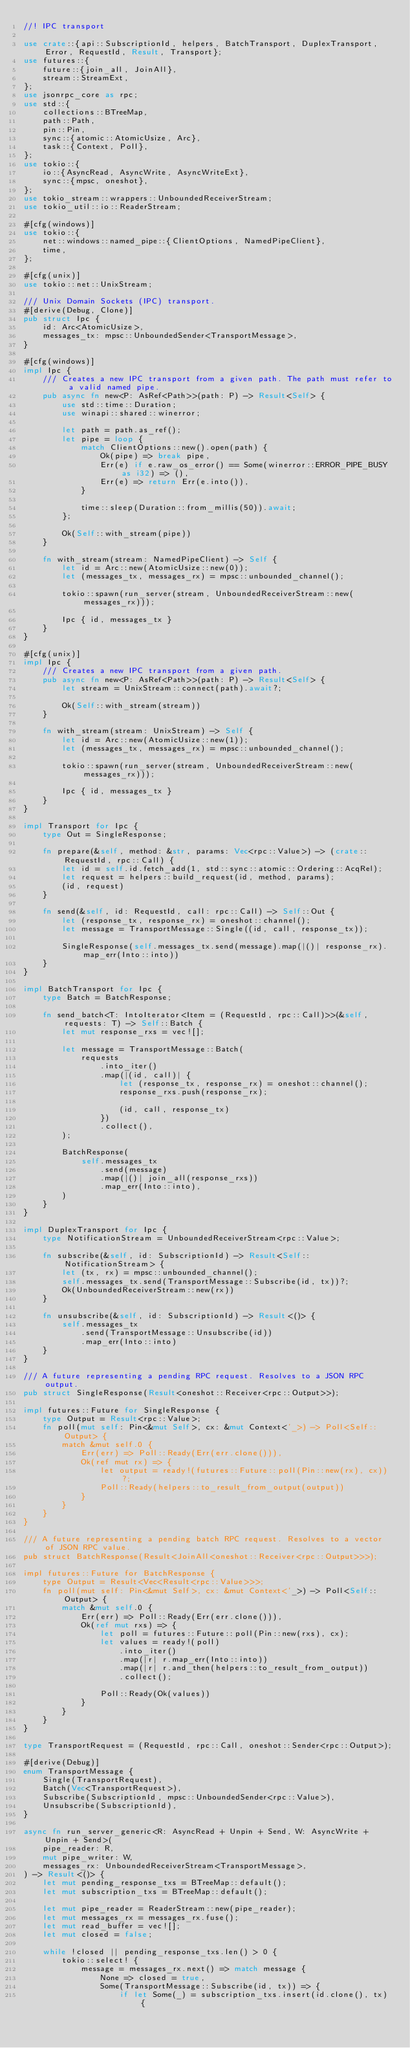<code> <loc_0><loc_0><loc_500><loc_500><_Rust_>//! IPC transport

use crate::{api::SubscriptionId, helpers, BatchTransport, DuplexTransport, Error, RequestId, Result, Transport};
use futures::{
    future::{join_all, JoinAll},
    stream::StreamExt,
};
use jsonrpc_core as rpc;
use std::{
    collections::BTreeMap,
    path::Path,
    pin::Pin,
    sync::{atomic::AtomicUsize, Arc},
    task::{Context, Poll},
};
use tokio::{
    io::{AsyncRead, AsyncWrite, AsyncWriteExt},
    sync::{mpsc, oneshot},
};
use tokio_stream::wrappers::UnboundedReceiverStream;
use tokio_util::io::ReaderStream;

#[cfg(windows)]
use tokio::{
    net::windows::named_pipe::{ClientOptions, NamedPipeClient},
    time,
};

#[cfg(unix)]
use tokio::net::UnixStream;

/// Unix Domain Sockets (IPC) transport.
#[derive(Debug, Clone)]
pub struct Ipc {
    id: Arc<AtomicUsize>,
    messages_tx: mpsc::UnboundedSender<TransportMessage>,
}

#[cfg(windows)]
impl Ipc {
    /// Creates a new IPC transport from a given path. The path must refer to a valid named pipe.
    pub async fn new<P: AsRef<Path>>(path: P) -> Result<Self> {
        use std::time::Duration;
        use winapi::shared::winerror;

        let path = path.as_ref();
        let pipe = loop {
            match ClientOptions::new().open(path) {
                Ok(pipe) => break pipe,
                Err(e) if e.raw_os_error() == Some(winerror::ERROR_PIPE_BUSY as i32) => (),
                Err(e) => return Err(e.into()),
            }

            time::sleep(Duration::from_millis(50)).await;
        };

        Ok(Self::with_stream(pipe))
    }

    fn with_stream(stream: NamedPipeClient) -> Self {
        let id = Arc::new(AtomicUsize::new(0));
        let (messages_tx, messages_rx) = mpsc::unbounded_channel();

        tokio::spawn(run_server(stream, UnboundedReceiverStream::new(messages_rx)));

        Ipc { id, messages_tx }
    }
}

#[cfg(unix)]
impl Ipc {
    /// Creates a new IPC transport from a given path.
    pub async fn new<P: AsRef<Path>>(path: P) -> Result<Self> {
        let stream = UnixStream::connect(path).await?;

        Ok(Self::with_stream(stream))
    }

    fn with_stream(stream: UnixStream) -> Self {
        let id = Arc::new(AtomicUsize::new(1));
        let (messages_tx, messages_rx) = mpsc::unbounded_channel();

        tokio::spawn(run_server(stream, UnboundedReceiverStream::new(messages_rx)));

        Ipc { id, messages_tx }
    }
}

impl Transport for Ipc {
    type Out = SingleResponse;

    fn prepare(&self, method: &str, params: Vec<rpc::Value>) -> (crate::RequestId, rpc::Call) {
        let id = self.id.fetch_add(1, std::sync::atomic::Ordering::AcqRel);
        let request = helpers::build_request(id, method, params);
        (id, request)
    }

    fn send(&self, id: RequestId, call: rpc::Call) -> Self::Out {
        let (response_tx, response_rx) = oneshot::channel();
        let message = TransportMessage::Single((id, call, response_tx));

        SingleResponse(self.messages_tx.send(message).map(|()| response_rx).map_err(Into::into))
    }
}

impl BatchTransport for Ipc {
    type Batch = BatchResponse;

    fn send_batch<T: IntoIterator<Item = (RequestId, rpc::Call)>>(&self, requests: T) -> Self::Batch {
        let mut response_rxs = vec![];

        let message = TransportMessage::Batch(
            requests
                .into_iter()
                .map(|(id, call)| {
                    let (response_tx, response_rx) = oneshot::channel();
                    response_rxs.push(response_rx);

                    (id, call, response_tx)
                })
                .collect(),
        );

        BatchResponse(
            self.messages_tx
                .send(message)
                .map(|()| join_all(response_rxs))
                .map_err(Into::into),
        )
    }
}

impl DuplexTransport for Ipc {
    type NotificationStream = UnboundedReceiverStream<rpc::Value>;

    fn subscribe(&self, id: SubscriptionId) -> Result<Self::NotificationStream> {
        let (tx, rx) = mpsc::unbounded_channel();
        self.messages_tx.send(TransportMessage::Subscribe(id, tx))?;
        Ok(UnboundedReceiverStream::new(rx))
    }

    fn unsubscribe(&self, id: SubscriptionId) -> Result<()> {
        self.messages_tx
            .send(TransportMessage::Unsubscribe(id))
            .map_err(Into::into)
    }
}

/// A future representing a pending RPC request. Resolves to a JSON RPC output.
pub struct SingleResponse(Result<oneshot::Receiver<rpc::Output>>);

impl futures::Future for SingleResponse {
    type Output = Result<rpc::Value>;
    fn poll(mut self: Pin<&mut Self>, cx: &mut Context<'_>) -> Poll<Self::Output> {
        match &mut self.0 {
            Err(err) => Poll::Ready(Err(err.clone())),
            Ok(ref mut rx) => {
                let output = ready!(futures::Future::poll(Pin::new(rx), cx))?;
                Poll::Ready(helpers::to_result_from_output(output))
            }
        }
    }
}

/// A future representing a pending batch RPC request. Resolves to a vector of JSON RPC value.
pub struct BatchResponse(Result<JoinAll<oneshot::Receiver<rpc::Output>>>);

impl futures::Future for BatchResponse {
    type Output = Result<Vec<Result<rpc::Value>>>;
    fn poll(mut self: Pin<&mut Self>, cx: &mut Context<'_>) -> Poll<Self::Output> {
        match &mut self.0 {
            Err(err) => Poll::Ready(Err(err.clone())),
            Ok(ref mut rxs) => {
                let poll = futures::Future::poll(Pin::new(rxs), cx);
                let values = ready!(poll)
                    .into_iter()
                    .map(|r| r.map_err(Into::into))
                    .map(|r| r.and_then(helpers::to_result_from_output))
                    .collect();

                Poll::Ready(Ok(values))
            }
        }
    }
}

type TransportRequest = (RequestId, rpc::Call, oneshot::Sender<rpc::Output>);

#[derive(Debug)]
enum TransportMessage {
    Single(TransportRequest),
    Batch(Vec<TransportRequest>),
    Subscribe(SubscriptionId, mpsc::UnboundedSender<rpc::Value>),
    Unsubscribe(SubscriptionId),
}

async fn run_server_generic<R: AsyncRead + Unpin + Send, W: AsyncWrite + Unpin + Send>(
    pipe_reader: R,
    mut pipe_writer: W,
    messages_rx: UnboundedReceiverStream<TransportMessage>,
) -> Result<()> {
    let mut pending_response_txs = BTreeMap::default();
    let mut subscription_txs = BTreeMap::default();

    let mut pipe_reader = ReaderStream::new(pipe_reader);
    let mut messages_rx = messages_rx.fuse();
    let mut read_buffer = vec![];
    let mut closed = false;

    while !closed || pending_response_txs.len() > 0 {
        tokio::select! {
            message = messages_rx.next() => match message {
                None => closed = true,
                Some(TransportMessage::Subscribe(id, tx)) => {
                    if let Some(_) = subscription_txs.insert(id.clone(), tx) {</code> 